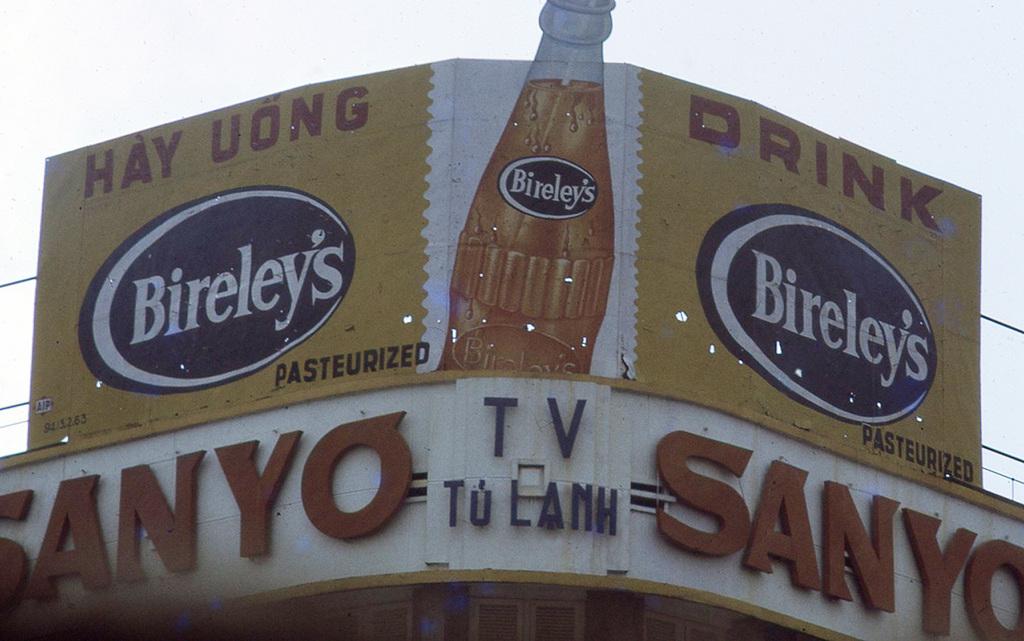What is the brand of the drink being advertised?
Keep it short and to the point. Bireley's. Is the drink pasteurized or no?
Your answer should be very brief. Yes. 